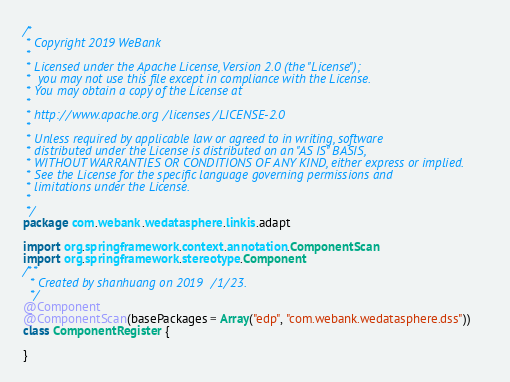<code> <loc_0><loc_0><loc_500><loc_500><_Scala_>/*
 * Copyright 2019 WeBank
 *
 * Licensed under the Apache License, Version 2.0 (the "License");
 *  you may not use this file except in compliance with the License.
 * You may obtain a copy of the License at
 *
 * http://www.apache.org/licenses/LICENSE-2.0
 *
 * Unless required by applicable law or agreed to in writing, software
 * distributed under the License is distributed on an "AS IS" BASIS,
 * WITHOUT WARRANTIES OR CONDITIONS OF ANY KIND, either express or implied.
 * See the License for the specific language governing permissions and
 * limitations under the License.
 *
 */
package com.webank.wedatasphere.linkis.adapt

import org.springframework.context.annotation.ComponentScan
import org.springframework.stereotype.Component
/**
  * Created by shanhuang on 2019/1/23.
  */
@Component
@ComponentScan(basePackages = Array("edp", "com.webank.wedatasphere.dss"))
class ComponentRegister {

}
</code> 